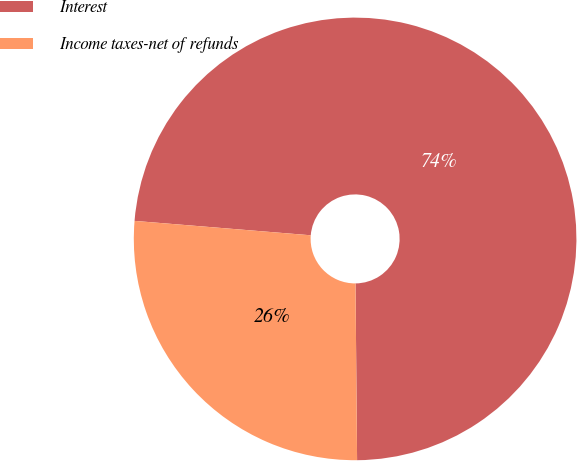Convert chart. <chart><loc_0><loc_0><loc_500><loc_500><pie_chart><fcel>Interest<fcel>Income taxes-net of refunds<nl><fcel>73.56%<fcel>26.44%<nl></chart> 